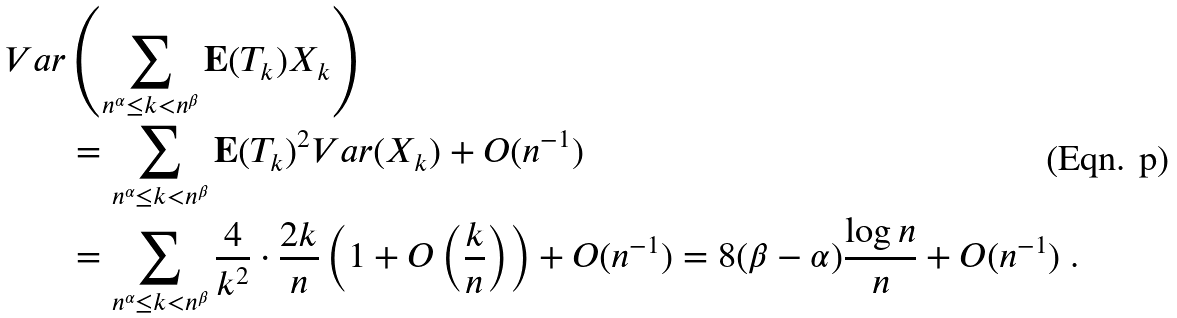Convert formula to latex. <formula><loc_0><loc_0><loc_500><loc_500>V a r & \left ( \sum _ { n ^ { \alpha } \leq k < n ^ { \beta } } \mathbf E ( T _ { k } ) X _ { k } \right ) \\ & = \sum _ { n ^ { \alpha } \leq k < n ^ { \beta } } \mathbf E ( T _ { k } ) ^ { 2 } V a r ( X _ { k } ) + O ( n ^ { - 1 } ) \\ & = \sum _ { n ^ { \alpha } \leq k < n ^ { \beta } } \frac { 4 } { k ^ { 2 } } \cdot \frac { 2 k } { n } \left ( 1 + O \left ( \frac { k } { n } \right ) \right ) + O ( n ^ { - 1 } ) = 8 ( \beta - \alpha ) \frac { \log n } { n } + O ( n ^ { - 1 } ) \ .</formula> 